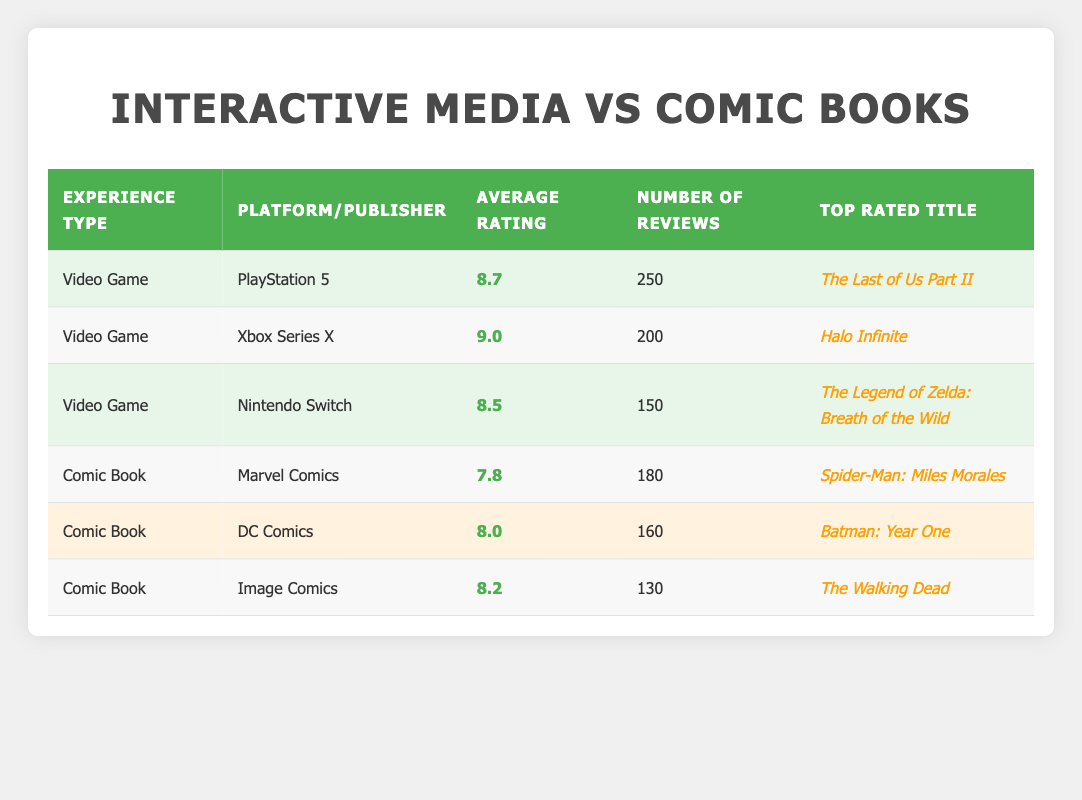What is the average rating for video games? To find the average rating for video games, we look at the average ratings provided in the table: 8.7 (PS5), 9.0 (Xbox Series X), and 8.5 (Nintendo Switch). Then we sum these ratings: 8.7 + 9.0 + 8.5 = 26.2. There are 3 video games, so we divide by 3: 26.2 / 3 = 8.733.
Answer: 8.7 Which comic book has the highest average rating? By examining the average ratings for comic books, we find: Marvel Comics at 7.8, DC Comics at 8.0, and Image Comics at 8.2. The highest average rating is 8.2 for Image Comics.
Answer: The Walking Dead What is the average number of reviews for comic books? We calculate the average number of reviews for comic books by adding the reviews: 180 (Marvel) + 160 (DC) + 130 (Image) = 470. There are 3 comic books, so we divide: 470 / 3 = 156.67.
Answer: 156.67 True or False: The Xbox Series X has the highest average rating. By checking the ratings, we see the Xbox Series X has an average rating of 9.0, which is higher than the other platforms—PS5 at 8.7 and Nintendo Switch at 8.5. So the statement is true.
Answer: True What is the difference between the highest video game rating and the highest comic book rating? The highest rating among video games is 9.0 (Xbox Series X) and the highest for comic books is 8.2 (Image Comics). We find the difference by subtracting: 9.0 - 8.2 = 0.8.
Answer: 0.8 Which platform has the lowest average rating among video games? We can see from the table the average ratings for the platforms: 8.7 (PS5), 9.0 (Xbox Series X), and 8.5 (Nintendo Switch). The lowest is the Nintendo Switch with an average rating of 8.5.
Answer: Nintendo Switch What is the total number of reviews for all video games combined? To find the total number of reviews for video games, we sum the individual review counts: 250 (PS5) + 200 (Xbox Series X) + 150 (Nintendo Switch) = 600.
Answer: 600 Is the top-rated comic book from Marvel Comics? The top-rated comic book according to the table is "Spider-Man: Miles Morales" from Marvel, which has an average rating of 7.8. This indicates the statement is true.
Answer: True 